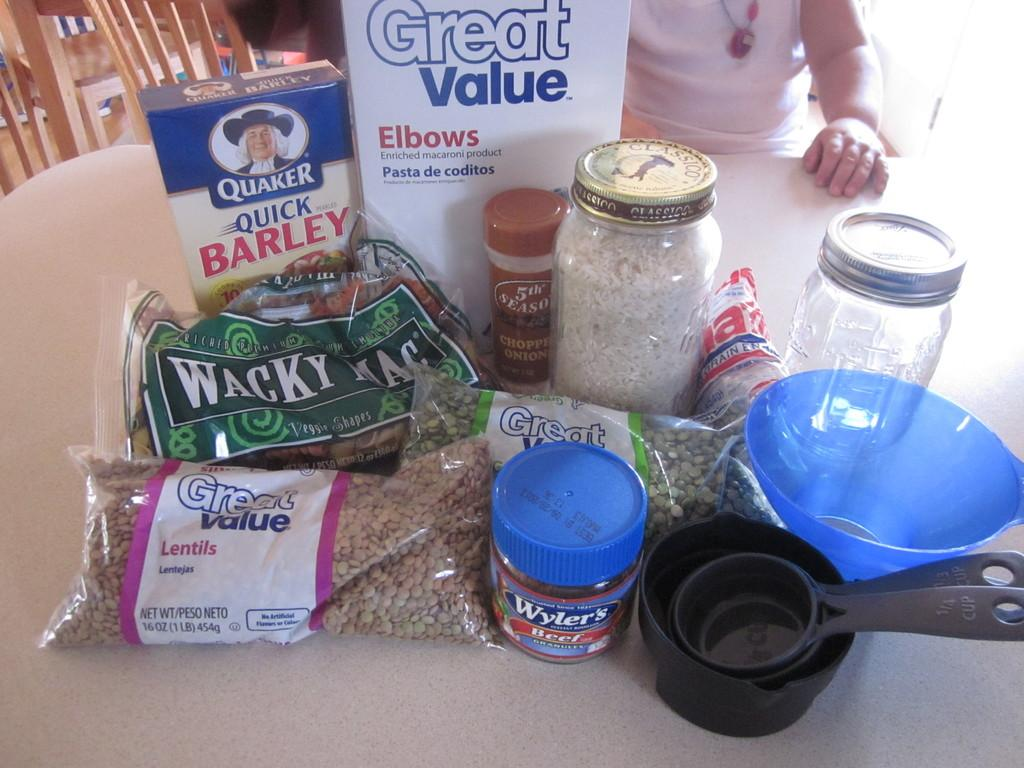Provide a one-sentence caption for the provided image. A collection of dry goods, a few of them by Great Value, sit on a table. 